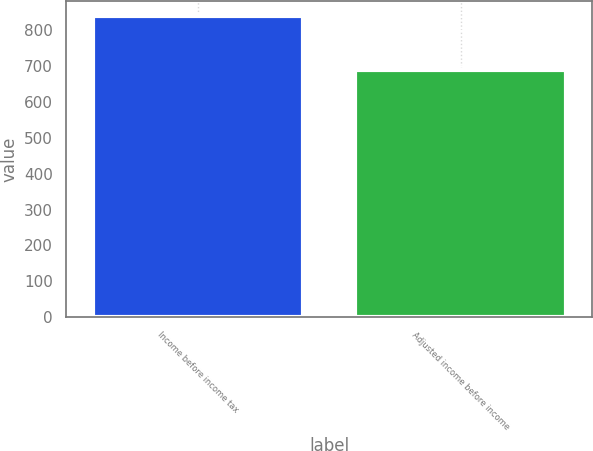Convert chart to OTSL. <chart><loc_0><loc_0><loc_500><loc_500><bar_chart><fcel>Income before income tax<fcel>Adjusted income before income<nl><fcel>838<fcel>689<nl></chart> 